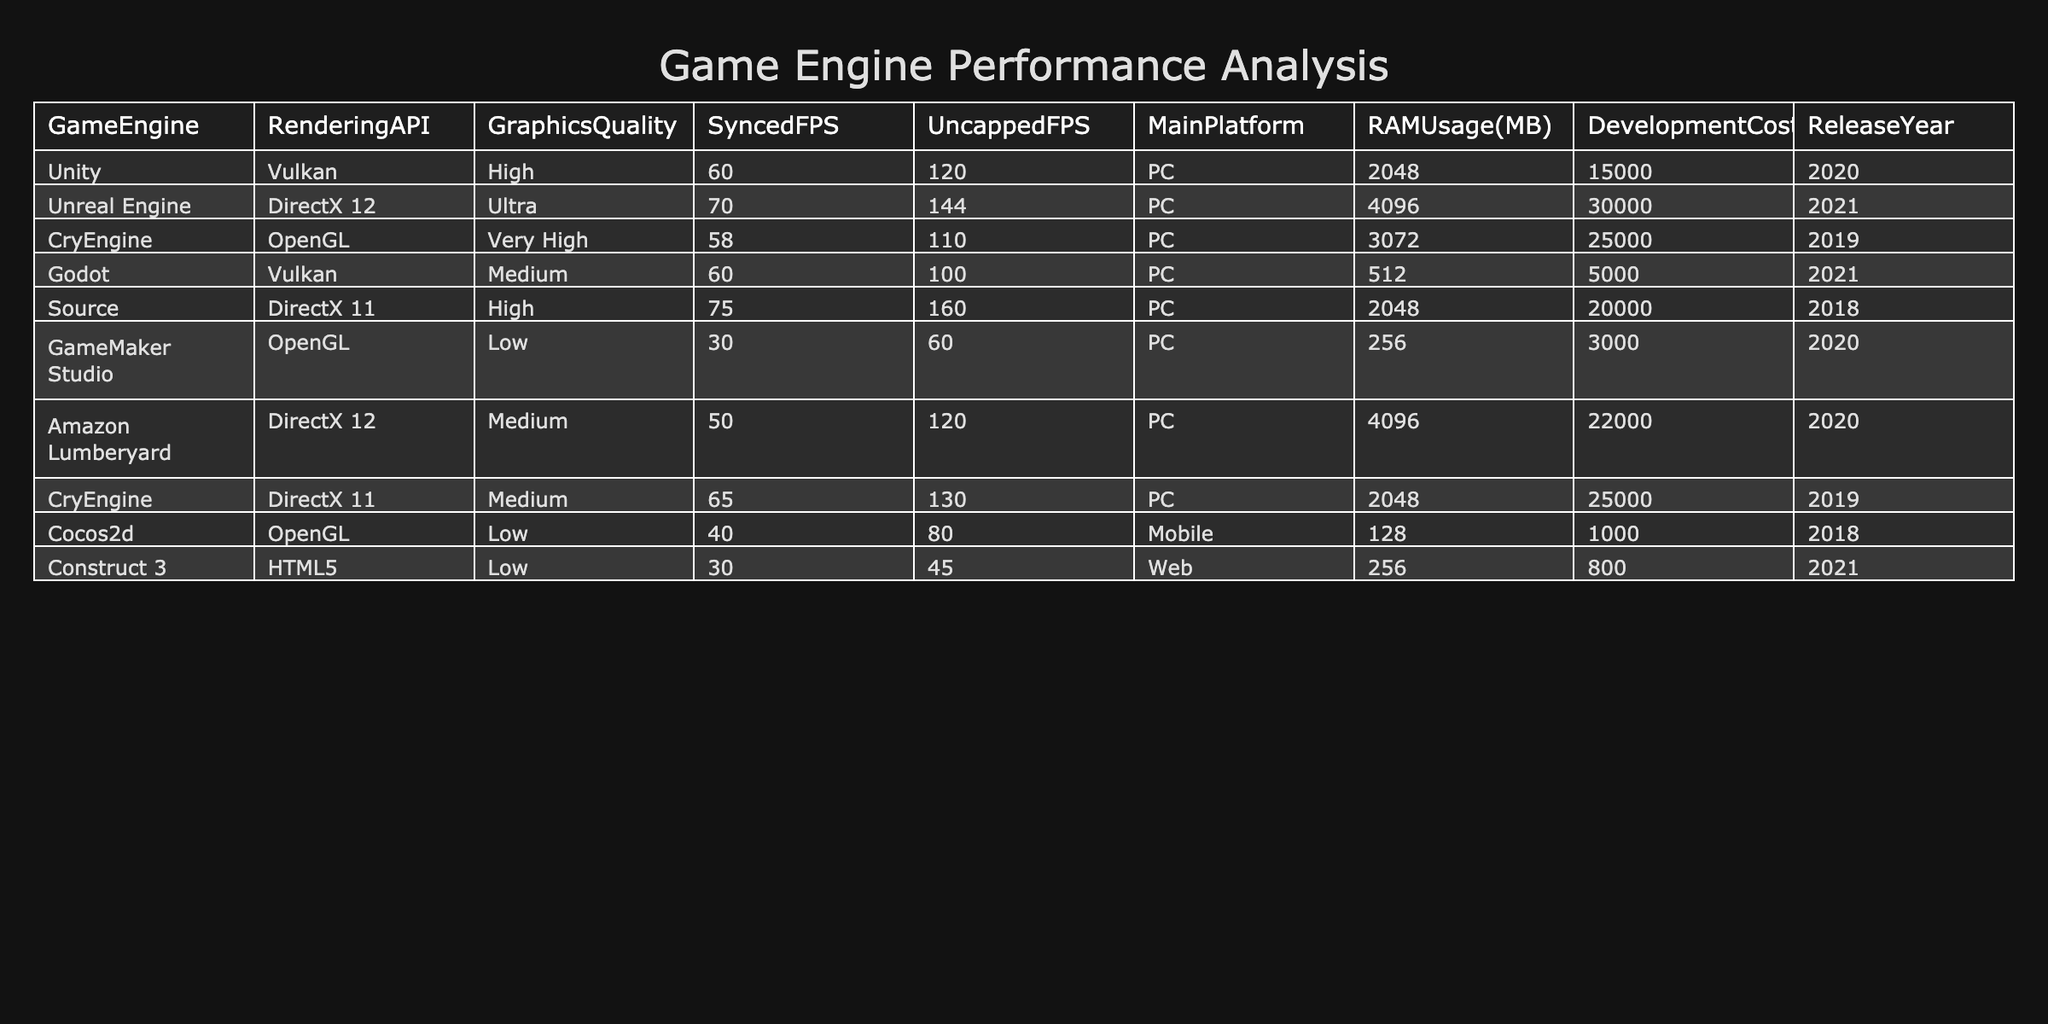What is the rendering API used by Unreal Engine? The table shows the details for each game engine, including the rendering API. By locating the row for Unreal Engine, we see that it uses DirectX 12.
Answer: DirectX 12 Which game engine has the highest uncapped FPS? The table lists the uncapped FPS for each game engine. By comparing the values in the Uncapped FPS column, we find that Source has the highest uncapped FPS at 160.
Answer: Source What is the average RAM usage of the game engines listed? To find the average RAM usage, we first sum the RAM usage values: 2048 + 4096 + 3072 + 512 + 2048 + 256 + 4096 + 2048 + 128 + 256 = 13208 MB. Then, we divide by the number of game engines (10), resulting in an average of 1320.8 MB.
Answer: 1320.8 MB Is CryEngine more expensive to develop than GameMaker Studio? We compare the Development Cost values for both game engines. CryEngine has a development cost of 25000 while GameMaker Studio's cost is 3000, making CryEngine more expensive.
Answer: Yes What is the difference in RAM usage between Unity and Cocos2d? We look at the RAM usage for Unity (2048 MB) and Cocos2d (128 MB). The difference is calculated as 2048 - 128 = 1920 MB.
Answer: 1920 MB Which game engines have a synced FPS of 60 or higher? We check the Synced FPS column for each engine. The engines with a synced FPS of 60 or higher are Unity (60), Unreal Engine (70), Source (75), and CryEngine (65).
Answer: Unity, Unreal Engine, Source, CryEngine How many game engines were released in or after 2021? From the Release Year column, we filter for years 2021 and onwards. The engines released in or after 2021 are Unreal Engine (2021), Godot (2021), and Construct 3 (2021), totaling 3 engines.
Answer: 3 Which game engine has the lowest graphics quality and what is its RAM usage? By scanning the Graphics Quality column, we find that GameMaker Studio has the lowest graphics quality listed as Low. Its RAM usage is 256 MB, as shown in the RAM Usage column.
Answer: GameMaker Studio, 256 MB Is the average development cost of game engines higher or lower than 20000? We calculate the average development cost: (15000 + 30000 + 25000 + 5000 + 20000 + 3000 + 22000 + 25000 + 1000 + 800) / 10 = 17380. The average cost is lower than 20000.
Answer: Lower 